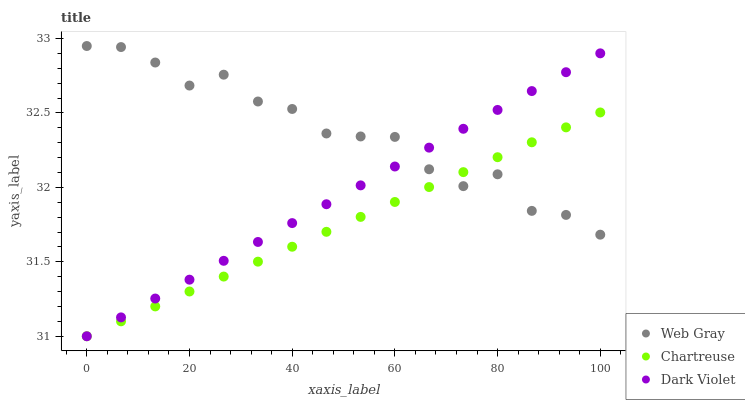Does Chartreuse have the minimum area under the curve?
Answer yes or no. Yes. Does Web Gray have the maximum area under the curve?
Answer yes or no. Yes. Does Dark Violet have the minimum area under the curve?
Answer yes or no. No. Does Dark Violet have the maximum area under the curve?
Answer yes or no. No. Is Chartreuse the smoothest?
Answer yes or no. Yes. Is Web Gray the roughest?
Answer yes or no. Yes. Is Dark Violet the smoothest?
Answer yes or no. No. Is Dark Violet the roughest?
Answer yes or no. No. Does Chartreuse have the lowest value?
Answer yes or no. Yes. Does Web Gray have the lowest value?
Answer yes or no. No. Does Web Gray have the highest value?
Answer yes or no. Yes. Does Dark Violet have the highest value?
Answer yes or no. No. Does Chartreuse intersect Dark Violet?
Answer yes or no. Yes. Is Chartreuse less than Dark Violet?
Answer yes or no. No. Is Chartreuse greater than Dark Violet?
Answer yes or no. No. 